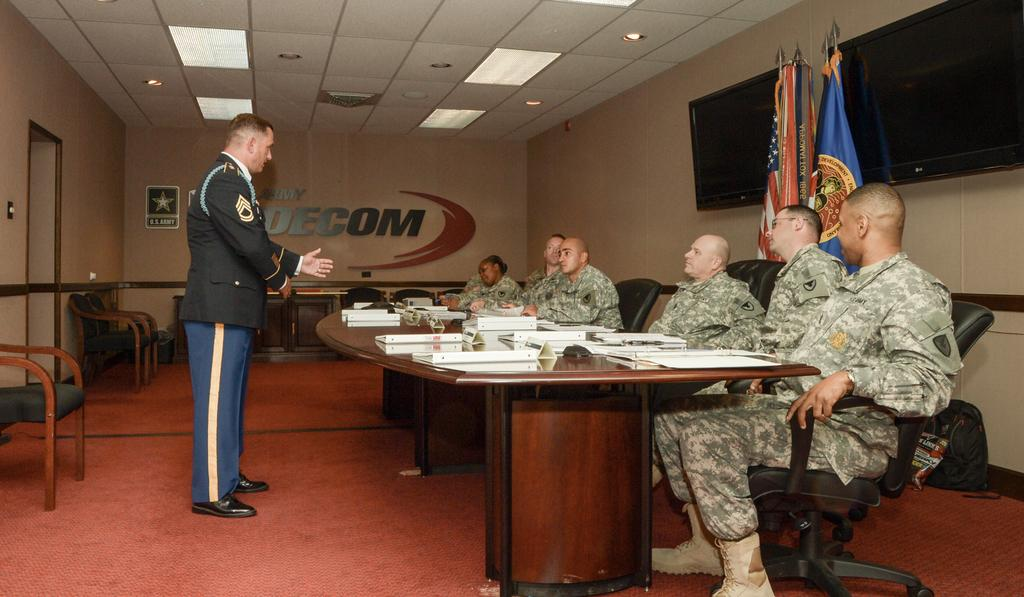What type of people are present in the image? There is a group of army officers in the image. What is happening in the image? There is a man speaking in front of the army officers. Can you describe the setting where the event is taking place? The setting appears to be a meeting room. Can you tell me how deep the lake is in the image? There is no lake present in the image. What sense is the man speaking to the army officers using in the image? The image does not provide information about the sense being used by the man speaking to the army officers. 